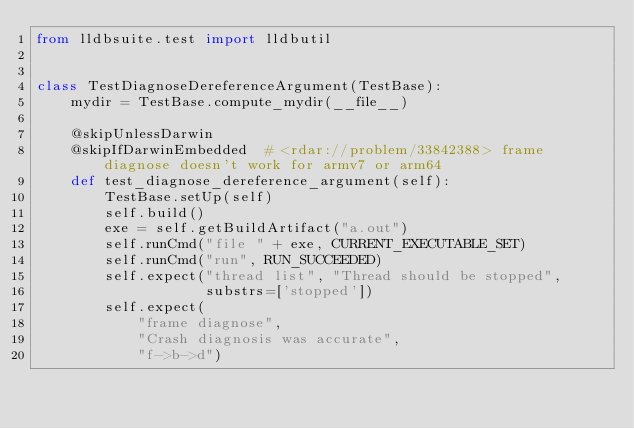Convert code to text. <code><loc_0><loc_0><loc_500><loc_500><_Python_>from lldbsuite.test import lldbutil


class TestDiagnoseDereferenceArgument(TestBase):
    mydir = TestBase.compute_mydir(__file__)

    @skipUnlessDarwin
    @skipIfDarwinEmbedded  # <rdar://problem/33842388> frame diagnose doesn't work for armv7 or arm64
    def test_diagnose_dereference_argument(self):
        TestBase.setUp(self)
        self.build()
        exe = self.getBuildArtifact("a.out")
        self.runCmd("file " + exe, CURRENT_EXECUTABLE_SET)
        self.runCmd("run", RUN_SUCCEEDED)
        self.expect("thread list", "Thread should be stopped",
                    substrs=['stopped'])
        self.expect(
            "frame diagnose",
            "Crash diagnosis was accurate",
            "f->b->d")
</code> 